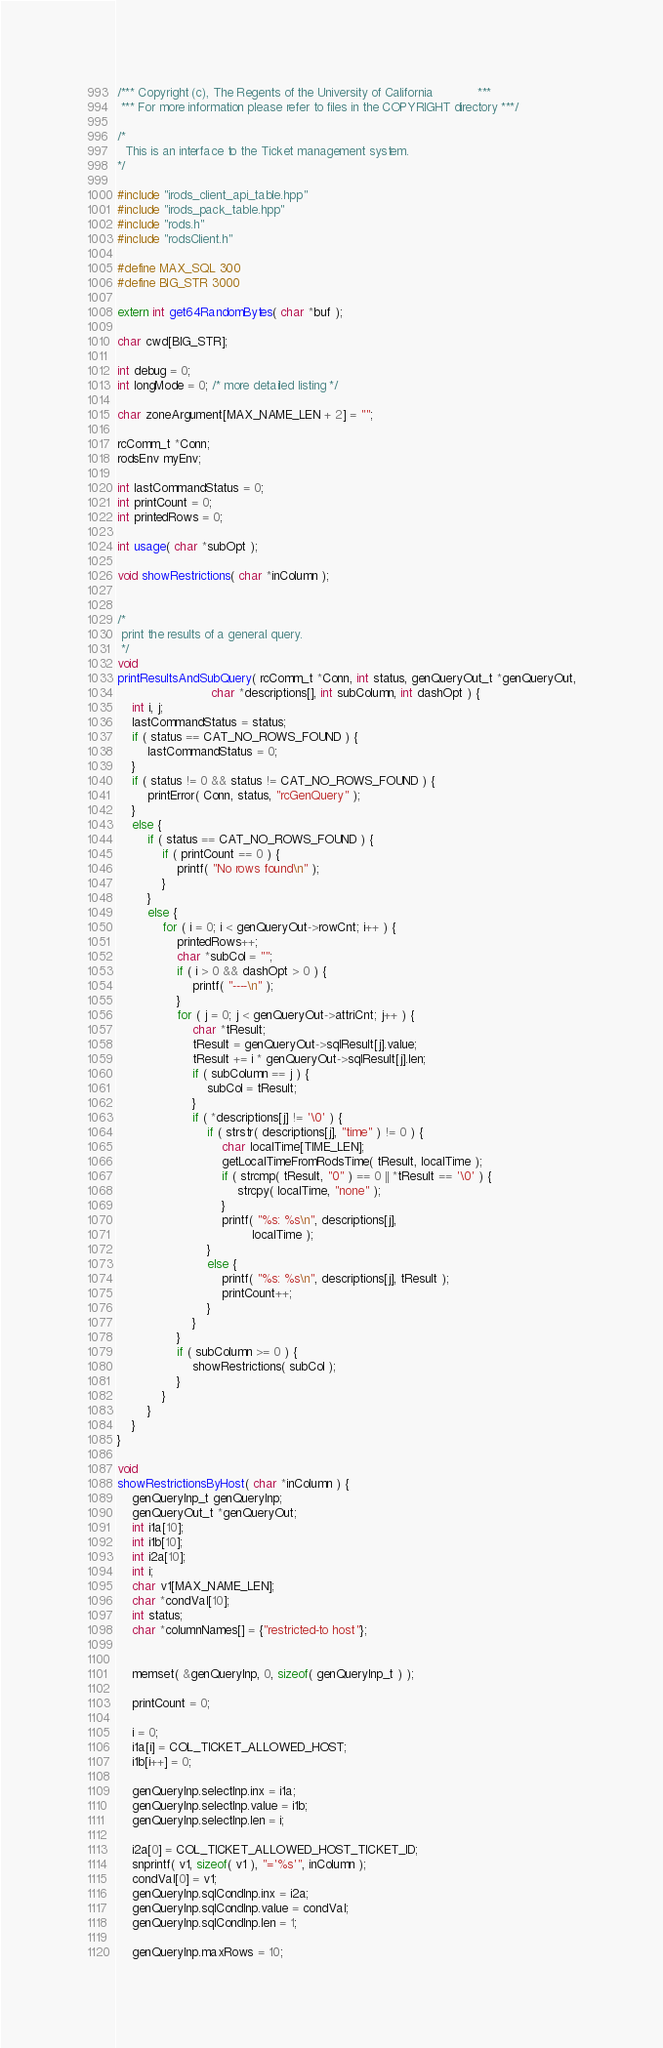Convert code to text. <code><loc_0><loc_0><loc_500><loc_500><_C++_>/*** Copyright (c), The Regents of the University of California            ***
 *** For more information please refer to files in the COPYRIGHT directory ***/

/*
  This is an interface to the Ticket management system.
*/

#include "irods_client_api_table.hpp"
#include "irods_pack_table.hpp"
#include "rods.h"
#include "rodsClient.h"

#define MAX_SQL 300
#define BIG_STR 3000

extern int get64RandomBytes( char *buf );

char cwd[BIG_STR];

int debug = 0;
int longMode = 0; /* more detailed listing */

char zoneArgument[MAX_NAME_LEN + 2] = "";

rcComm_t *Conn;
rodsEnv myEnv;

int lastCommandStatus = 0;
int printCount = 0;
int printedRows = 0;

int usage( char *subOpt );

void showRestrictions( char *inColumn );


/*
 print the results of a general query.
 */
void
printResultsAndSubQuery( rcComm_t *Conn, int status, genQueryOut_t *genQueryOut,
                         char *descriptions[], int subColumn, int dashOpt ) {
    int i, j;
    lastCommandStatus = status;
    if ( status == CAT_NO_ROWS_FOUND ) {
        lastCommandStatus = 0;
    }
    if ( status != 0 && status != CAT_NO_ROWS_FOUND ) {
        printError( Conn, status, "rcGenQuery" );
    }
    else {
        if ( status == CAT_NO_ROWS_FOUND ) {
            if ( printCount == 0 ) {
                printf( "No rows found\n" );
            }
        }
        else {
            for ( i = 0; i < genQueryOut->rowCnt; i++ ) {
                printedRows++;
                char *subCol = "";
                if ( i > 0 && dashOpt > 0 ) {
                    printf( "----\n" );
                }
                for ( j = 0; j < genQueryOut->attriCnt; j++ ) {
                    char *tResult;
                    tResult = genQueryOut->sqlResult[j].value;
                    tResult += i * genQueryOut->sqlResult[j].len;
                    if ( subColumn == j ) {
                        subCol = tResult;
                    }
                    if ( *descriptions[j] != '\0' ) {
                        if ( strstr( descriptions[j], "time" ) != 0 ) {
                            char localTime[TIME_LEN];
                            getLocalTimeFromRodsTime( tResult, localTime );
                            if ( strcmp( tResult, "0" ) == 0 || *tResult == '\0' ) {
                                strcpy( localTime, "none" );
                            }
                            printf( "%s: %s\n", descriptions[j],
                                    localTime );
                        }
                        else {
                            printf( "%s: %s\n", descriptions[j], tResult );
                            printCount++;
                        }
                    }
                }
                if ( subColumn >= 0 ) {
                    showRestrictions( subCol );
                }
            }
        }
    }
}

void
showRestrictionsByHost( char *inColumn ) {
    genQueryInp_t genQueryInp;
    genQueryOut_t *genQueryOut;
    int i1a[10];
    int i1b[10];
    int i2a[10];
    int i;
    char v1[MAX_NAME_LEN];
    char *condVal[10];
    int status;
    char *columnNames[] = {"restricted-to host"};


    memset( &genQueryInp, 0, sizeof( genQueryInp_t ) );

    printCount = 0;

    i = 0;
    i1a[i] = COL_TICKET_ALLOWED_HOST;
    i1b[i++] = 0;

    genQueryInp.selectInp.inx = i1a;
    genQueryInp.selectInp.value = i1b;
    genQueryInp.selectInp.len = i;

    i2a[0] = COL_TICKET_ALLOWED_HOST_TICKET_ID;
    snprintf( v1, sizeof( v1 ), "='%s'", inColumn );
    condVal[0] = v1;
    genQueryInp.sqlCondInp.inx = i2a;
    genQueryInp.sqlCondInp.value = condVal;
    genQueryInp.sqlCondInp.len = 1;

    genQueryInp.maxRows = 10;</code> 